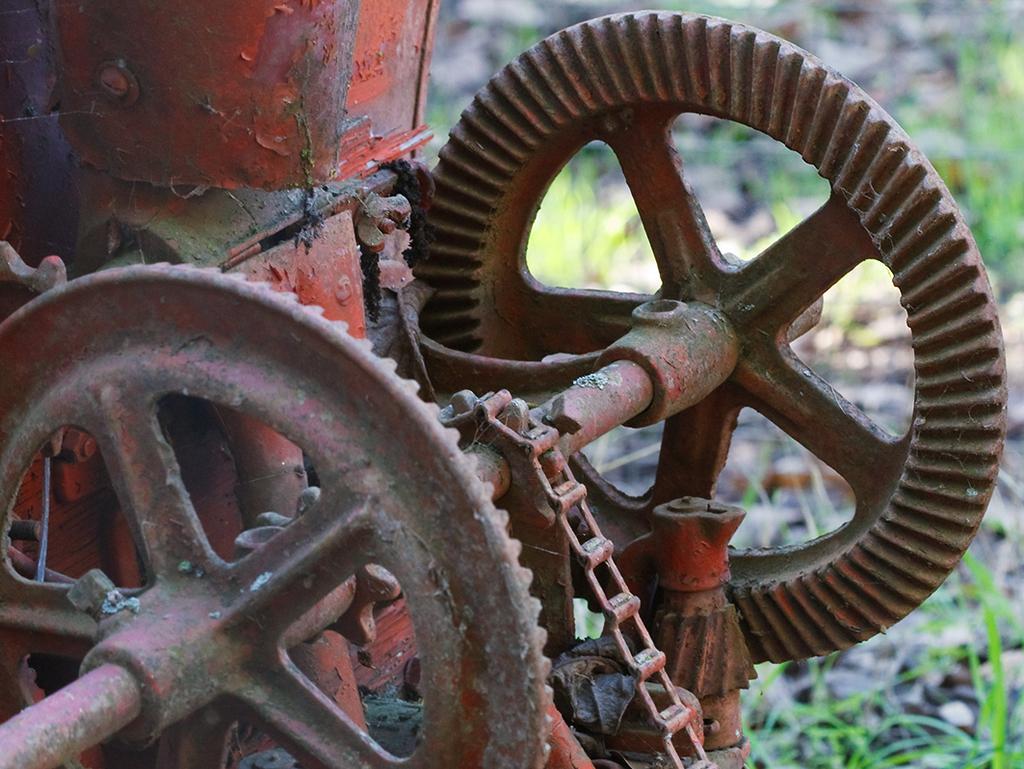Could you give a brief overview of what you see in this image? In this image I see an equipment which is of brown and red in color and in the background I see the grass. 